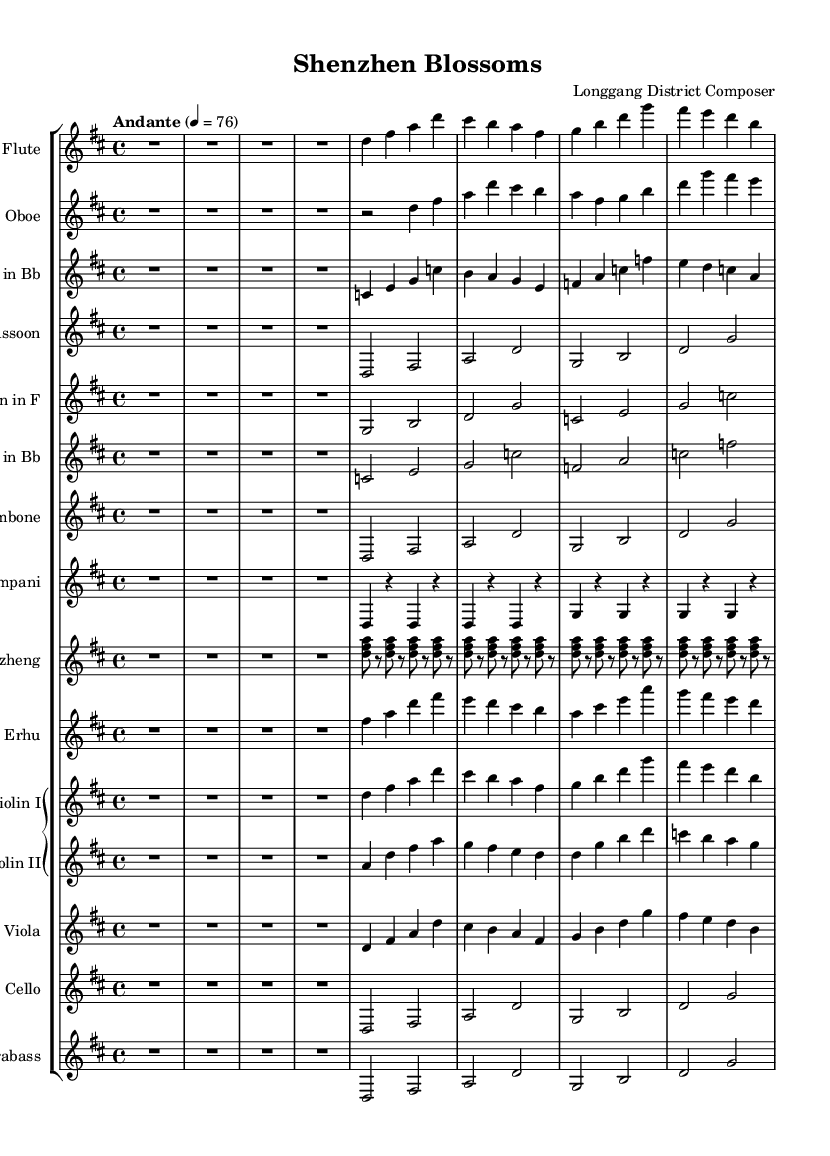What is the key signature of this music? The key signature is indicated at the beginning of the score and is D major, which has two sharps (F# and C#).
Answer: D major What is the time signature of the composition? The time signature appears next to the key signature at the start and is 4/4, indicating four beats per measure.
Answer: 4/4 What is the tempo marking for the piece? The tempo marking is placed above the staff, showing that the piece should be played "Andante" at a speed of 76 beats per minute.
Answer: Andante, 76 Which instruments are included in this orchestration? By examining the score, we can see that it includes woodwinds (flute, oboe, clarinet, and bassoon), brass (horn, trumpet, and trombone), percussion (timpani), strings (guzheng, erhu, violin, viola, cello, and contrabass).
Answer: Flute, Oboe, Clarinet, Bassoon, Horn, Trumpet, Trombone, Timpani, Guzheng, Erhu, Violin I, Violin II, Viola, Cello, Contrabass Which melodic instrument plays the main theme? The flute part is the first to introduce the main melodic theme, making it the lead instrument of the piece.
Answer: Flute How many measures are in the flute part? By counting the distinct measures in the flute music section, we find that it consists of four measures, as indicated by the bar lines.
Answer: 4 What is the overall mood conveyed by the orchestration in this composition? Considering that this is a Romantic orchestral composition celebrating Chinese cultural heritage, the instrumentation and melodic choices create a warm, expressive, and nostalgic mood typical of Romantic music.
Answer: Warm and nostalgic 